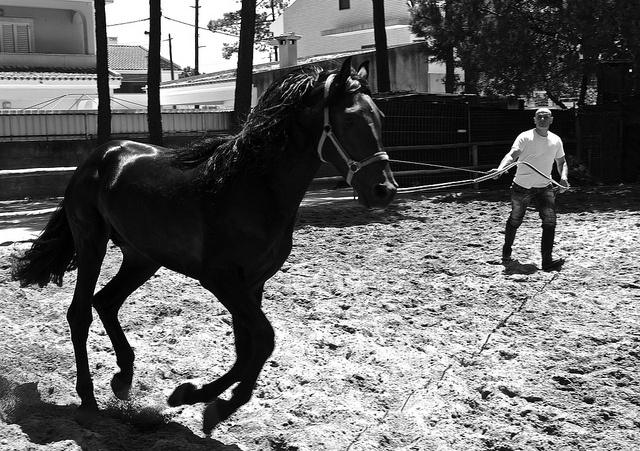Describe the objects in this image and their specific colors. I can see horse in gray, black, darkgray, and lightgray tones and people in gray, black, darkgray, and white tones in this image. 